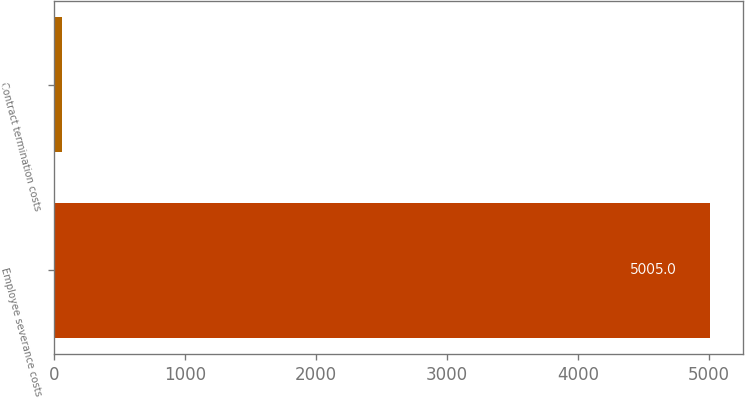Convert chart. <chart><loc_0><loc_0><loc_500><loc_500><bar_chart><fcel>Employee severance costs<fcel>Contract termination costs<nl><fcel>5005<fcel>61<nl></chart> 